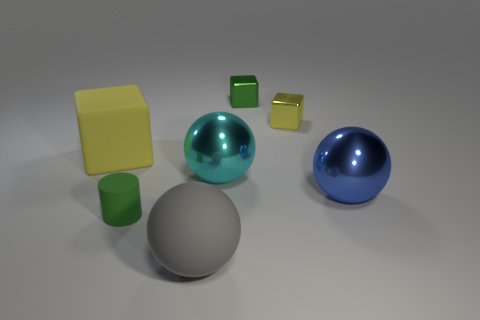Add 3 balls. How many objects exist? 10 Subtract all cylinders. How many objects are left? 6 Subtract 0 red blocks. How many objects are left? 7 Subtract all large blue things. Subtract all big matte balls. How many objects are left? 5 Add 1 green cubes. How many green cubes are left? 2 Add 6 tiny yellow matte cylinders. How many tiny yellow matte cylinders exist? 6 